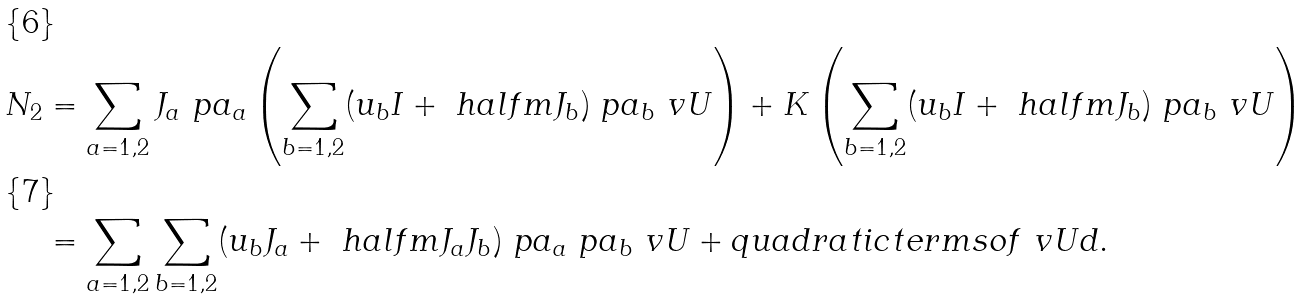<formula> <loc_0><loc_0><loc_500><loc_500>N _ { 2 } & = \sum _ { a = 1 , 2 } J _ { a } \ p a _ { a } \left ( \sum _ { b = 1 , 2 } ( u _ { b } I + \ h a l f m J _ { b } ) \ p a _ { b } \ v U \right ) + K \left ( \sum _ { b = 1 , 2 } ( u _ { b } I + \ h a l f m J _ { b } ) \ p a _ { b } \ v U \right ) \\ & = \sum _ { a = 1 , 2 } \sum _ { b = 1 , 2 } ( u _ { b } J _ { a } + \ h a l f m J _ { a } J _ { b } ) \ p a _ { a } \ p a _ { b } \ v U + q u a d r a t i c t e r m s o f \ v U d .</formula> 